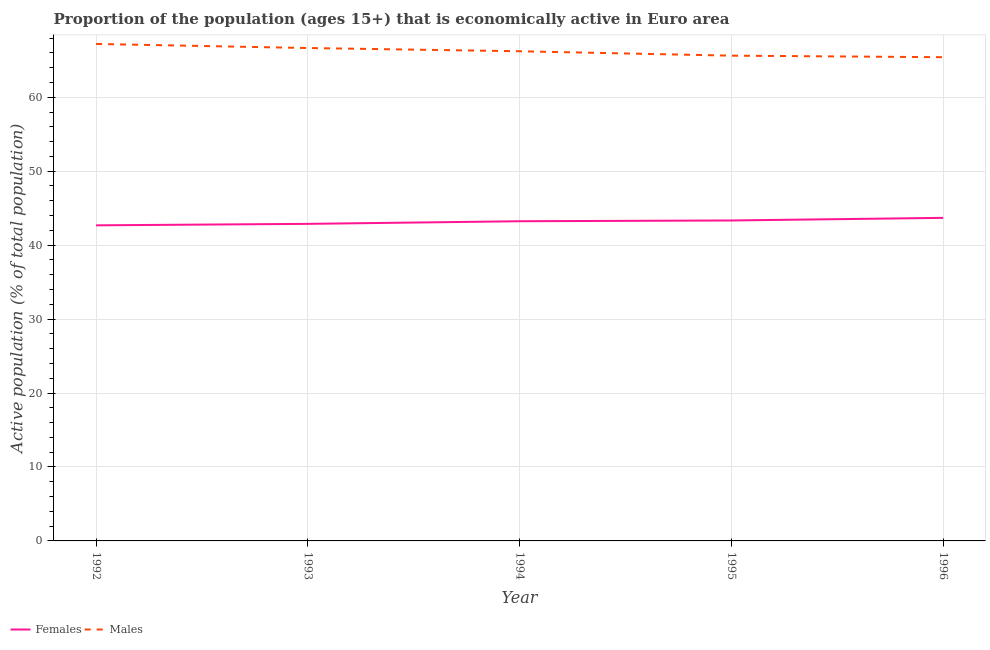How many different coloured lines are there?
Your answer should be compact. 2. What is the percentage of economically active male population in 1992?
Ensure brevity in your answer.  67.2. Across all years, what is the maximum percentage of economically active female population?
Make the answer very short. 43.69. Across all years, what is the minimum percentage of economically active female population?
Your response must be concise. 42.68. In which year was the percentage of economically active female population minimum?
Your answer should be very brief. 1992. What is the total percentage of economically active female population in the graph?
Make the answer very short. 215.8. What is the difference between the percentage of economically active female population in 1995 and that in 1996?
Give a very brief answer. -0.35. What is the difference between the percentage of economically active male population in 1996 and the percentage of economically active female population in 1994?
Keep it short and to the point. 22.18. What is the average percentage of economically active male population per year?
Your response must be concise. 66.22. In the year 1993, what is the difference between the percentage of economically active male population and percentage of economically active female population?
Provide a short and direct response. 23.78. What is the ratio of the percentage of economically active female population in 1993 to that in 1995?
Offer a terse response. 0.99. Is the percentage of economically active female population in 1993 less than that in 1996?
Provide a short and direct response. Yes. Is the difference between the percentage of economically active male population in 1993 and 1995 greater than the difference between the percentage of economically active female population in 1993 and 1995?
Offer a very short reply. Yes. What is the difference between the highest and the second highest percentage of economically active female population?
Provide a succinct answer. 0.35. What is the difference between the highest and the lowest percentage of economically active female population?
Give a very brief answer. 1.01. Is the sum of the percentage of economically active female population in 1992 and 1994 greater than the maximum percentage of economically active male population across all years?
Ensure brevity in your answer.  Yes. Does the percentage of economically active male population monotonically increase over the years?
Offer a terse response. No. How many lines are there?
Your answer should be compact. 2. Are the values on the major ticks of Y-axis written in scientific E-notation?
Your answer should be compact. No. Does the graph contain any zero values?
Your answer should be very brief. No. How are the legend labels stacked?
Offer a very short reply. Horizontal. What is the title of the graph?
Provide a succinct answer. Proportion of the population (ages 15+) that is economically active in Euro area. Does "Agricultural land" appear as one of the legend labels in the graph?
Keep it short and to the point. No. What is the label or title of the Y-axis?
Your answer should be compact. Active population (% of total population). What is the Active population (% of total population) of Females in 1992?
Keep it short and to the point. 42.68. What is the Active population (% of total population) in Males in 1992?
Your answer should be very brief. 67.2. What is the Active population (% of total population) of Females in 1993?
Ensure brevity in your answer.  42.88. What is the Active population (% of total population) in Males in 1993?
Keep it short and to the point. 66.65. What is the Active population (% of total population) of Females in 1994?
Provide a succinct answer. 43.23. What is the Active population (% of total population) of Males in 1994?
Give a very brief answer. 66.22. What is the Active population (% of total population) of Females in 1995?
Provide a succinct answer. 43.33. What is the Active population (% of total population) in Males in 1995?
Give a very brief answer. 65.62. What is the Active population (% of total population) in Females in 1996?
Provide a succinct answer. 43.69. What is the Active population (% of total population) of Males in 1996?
Give a very brief answer. 65.41. Across all years, what is the maximum Active population (% of total population) of Females?
Your answer should be compact. 43.69. Across all years, what is the maximum Active population (% of total population) of Males?
Offer a very short reply. 67.2. Across all years, what is the minimum Active population (% of total population) of Females?
Your answer should be compact. 42.68. Across all years, what is the minimum Active population (% of total population) of Males?
Offer a terse response. 65.41. What is the total Active population (% of total population) of Females in the graph?
Give a very brief answer. 215.8. What is the total Active population (% of total population) of Males in the graph?
Your answer should be compact. 331.11. What is the difference between the Active population (% of total population) of Females in 1992 and that in 1993?
Offer a very short reply. -0.2. What is the difference between the Active population (% of total population) of Males in 1992 and that in 1993?
Your answer should be very brief. 0.55. What is the difference between the Active population (% of total population) of Females in 1992 and that in 1994?
Provide a short and direct response. -0.55. What is the difference between the Active population (% of total population) of Males in 1992 and that in 1994?
Give a very brief answer. 0.99. What is the difference between the Active population (% of total population) of Females in 1992 and that in 1995?
Ensure brevity in your answer.  -0.66. What is the difference between the Active population (% of total population) of Males in 1992 and that in 1995?
Offer a very short reply. 1.58. What is the difference between the Active population (% of total population) of Females in 1992 and that in 1996?
Ensure brevity in your answer.  -1.01. What is the difference between the Active population (% of total population) in Males in 1992 and that in 1996?
Provide a succinct answer. 1.79. What is the difference between the Active population (% of total population) in Females in 1993 and that in 1994?
Ensure brevity in your answer.  -0.36. What is the difference between the Active population (% of total population) of Males in 1993 and that in 1994?
Offer a very short reply. 0.44. What is the difference between the Active population (% of total population) in Females in 1993 and that in 1995?
Your answer should be compact. -0.46. What is the difference between the Active population (% of total population) in Males in 1993 and that in 1995?
Keep it short and to the point. 1.03. What is the difference between the Active population (% of total population) of Females in 1993 and that in 1996?
Your answer should be compact. -0.81. What is the difference between the Active population (% of total population) in Males in 1993 and that in 1996?
Your answer should be compact. 1.24. What is the difference between the Active population (% of total population) in Females in 1994 and that in 1995?
Your response must be concise. -0.1. What is the difference between the Active population (% of total population) in Males in 1994 and that in 1995?
Your answer should be very brief. 0.6. What is the difference between the Active population (% of total population) in Females in 1994 and that in 1996?
Provide a short and direct response. -0.46. What is the difference between the Active population (% of total population) of Males in 1994 and that in 1996?
Your response must be concise. 0.8. What is the difference between the Active population (% of total population) in Females in 1995 and that in 1996?
Your answer should be very brief. -0.35. What is the difference between the Active population (% of total population) in Males in 1995 and that in 1996?
Make the answer very short. 0.21. What is the difference between the Active population (% of total population) of Females in 1992 and the Active population (% of total population) of Males in 1993?
Give a very brief answer. -23.98. What is the difference between the Active population (% of total population) of Females in 1992 and the Active population (% of total population) of Males in 1994?
Keep it short and to the point. -23.54. What is the difference between the Active population (% of total population) in Females in 1992 and the Active population (% of total population) in Males in 1995?
Give a very brief answer. -22.94. What is the difference between the Active population (% of total population) of Females in 1992 and the Active population (% of total population) of Males in 1996?
Ensure brevity in your answer.  -22.73. What is the difference between the Active population (% of total population) in Females in 1993 and the Active population (% of total population) in Males in 1994?
Offer a very short reply. -23.34. What is the difference between the Active population (% of total population) of Females in 1993 and the Active population (% of total population) of Males in 1995?
Give a very brief answer. -22.74. What is the difference between the Active population (% of total population) of Females in 1993 and the Active population (% of total population) of Males in 1996?
Your answer should be compact. -22.54. What is the difference between the Active population (% of total population) of Females in 1994 and the Active population (% of total population) of Males in 1995?
Provide a short and direct response. -22.39. What is the difference between the Active population (% of total population) of Females in 1994 and the Active population (% of total population) of Males in 1996?
Offer a terse response. -22.18. What is the difference between the Active population (% of total population) in Females in 1995 and the Active population (% of total population) in Males in 1996?
Give a very brief answer. -22.08. What is the average Active population (% of total population) of Females per year?
Give a very brief answer. 43.16. What is the average Active population (% of total population) of Males per year?
Ensure brevity in your answer.  66.22. In the year 1992, what is the difference between the Active population (% of total population) of Females and Active population (% of total population) of Males?
Make the answer very short. -24.53. In the year 1993, what is the difference between the Active population (% of total population) in Females and Active population (% of total population) in Males?
Your response must be concise. -23.78. In the year 1994, what is the difference between the Active population (% of total population) in Females and Active population (% of total population) in Males?
Your answer should be compact. -22.99. In the year 1995, what is the difference between the Active population (% of total population) in Females and Active population (% of total population) in Males?
Make the answer very short. -22.29. In the year 1996, what is the difference between the Active population (% of total population) of Females and Active population (% of total population) of Males?
Provide a short and direct response. -21.73. What is the ratio of the Active population (% of total population) in Females in 1992 to that in 1993?
Keep it short and to the point. 1. What is the ratio of the Active population (% of total population) of Males in 1992 to that in 1993?
Keep it short and to the point. 1.01. What is the ratio of the Active population (% of total population) in Females in 1992 to that in 1994?
Ensure brevity in your answer.  0.99. What is the ratio of the Active population (% of total population) of Males in 1992 to that in 1994?
Offer a terse response. 1.01. What is the ratio of the Active population (% of total population) of Males in 1992 to that in 1995?
Give a very brief answer. 1.02. What is the ratio of the Active population (% of total population) in Females in 1992 to that in 1996?
Ensure brevity in your answer.  0.98. What is the ratio of the Active population (% of total population) in Males in 1992 to that in 1996?
Provide a succinct answer. 1.03. What is the ratio of the Active population (% of total population) in Females in 1993 to that in 1994?
Make the answer very short. 0.99. What is the ratio of the Active population (% of total population) in Males in 1993 to that in 1994?
Give a very brief answer. 1.01. What is the ratio of the Active population (% of total population) of Males in 1993 to that in 1995?
Provide a succinct answer. 1.02. What is the ratio of the Active population (% of total population) of Females in 1993 to that in 1996?
Ensure brevity in your answer.  0.98. What is the ratio of the Active population (% of total population) in Males in 1993 to that in 1996?
Keep it short and to the point. 1.02. What is the ratio of the Active population (% of total population) of Females in 1994 to that in 1995?
Provide a succinct answer. 1. What is the ratio of the Active population (% of total population) in Males in 1994 to that in 1995?
Offer a very short reply. 1.01. What is the ratio of the Active population (% of total population) in Females in 1994 to that in 1996?
Your answer should be compact. 0.99. What is the ratio of the Active population (% of total population) of Males in 1994 to that in 1996?
Ensure brevity in your answer.  1.01. What is the ratio of the Active population (% of total population) in Females in 1995 to that in 1996?
Your answer should be compact. 0.99. What is the difference between the highest and the second highest Active population (% of total population) in Females?
Provide a succinct answer. 0.35. What is the difference between the highest and the second highest Active population (% of total population) of Males?
Provide a succinct answer. 0.55. What is the difference between the highest and the lowest Active population (% of total population) in Females?
Give a very brief answer. 1.01. What is the difference between the highest and the lowest Active population (% of total population) of Males?
Your answer should be very brief. 1.79. 